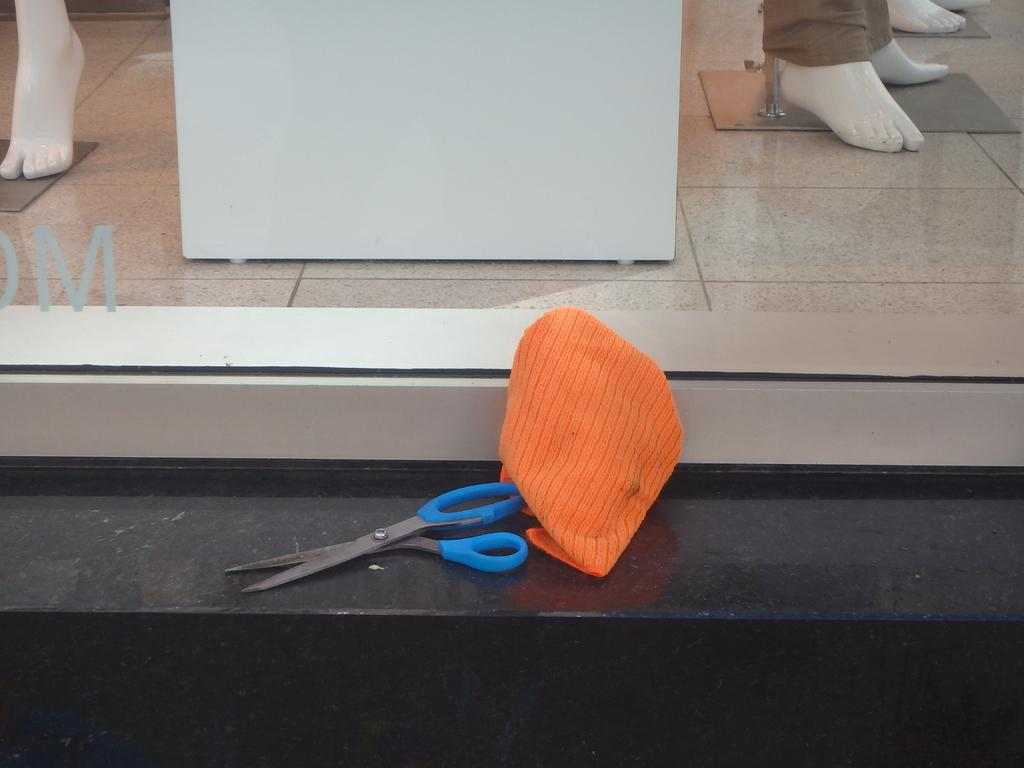What object is hanging on the wall in the image? There is a scissor on the wall in the image. What is the color of the cloth visible in the image? The cloth in the image is orange. What type of material is the window made of in the image? The window in the image is a glass window. What type of power can be seen flowing through the scissor in the image? There is no power flowing through the scissor in the image; it is a stationary object. 